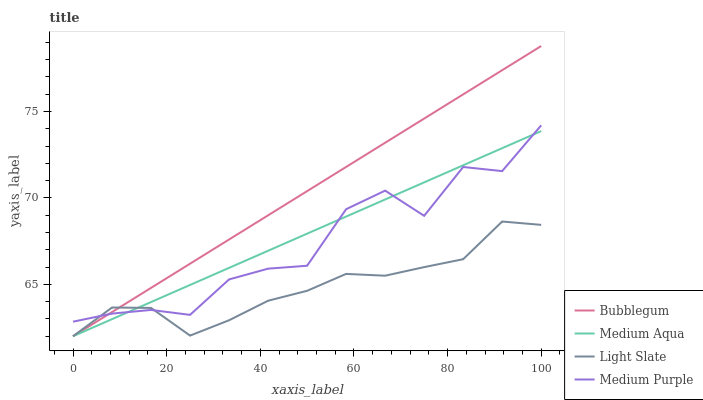Does Light Slate have the minimum area under the curve?
Answer yes or no. Yes. Does Bubblegum have the maximum area under the curve?
Answer yes or no. Yes. Does Medium Purple have the minimum area under the curve?
Answer yes or no. No. Does Medium Purple have the maximum area under the curve?
Answer yes or no. No. Is Medium Aqua the smoothest?
Answer yes or no. Yes. Is Medium Purple the roughest?
Answer yes or no. Yes. Is Medium Purple the smoothest?
Answer yes or no. No. Is Medium Aqua the roughest?
Answer yes or no. No. Does Light Slate have the lowest value?
Answer yes or no. Yes. Does Medium Purple have the lowest value?
Answer yes or no. No. Does Bubblegum have the highest value?
Answer yes or no. Yes. Does Medium Purple have the highest value?
Answer yes or no. No. Does Medium Purple intersect Light Slate?
Answer yes or no. Yes. Is Medium Purple less than Light Slate?
Answer yes or no. No. Is Medium Purple greater than Light Slate?
Answer yes or no. No. 